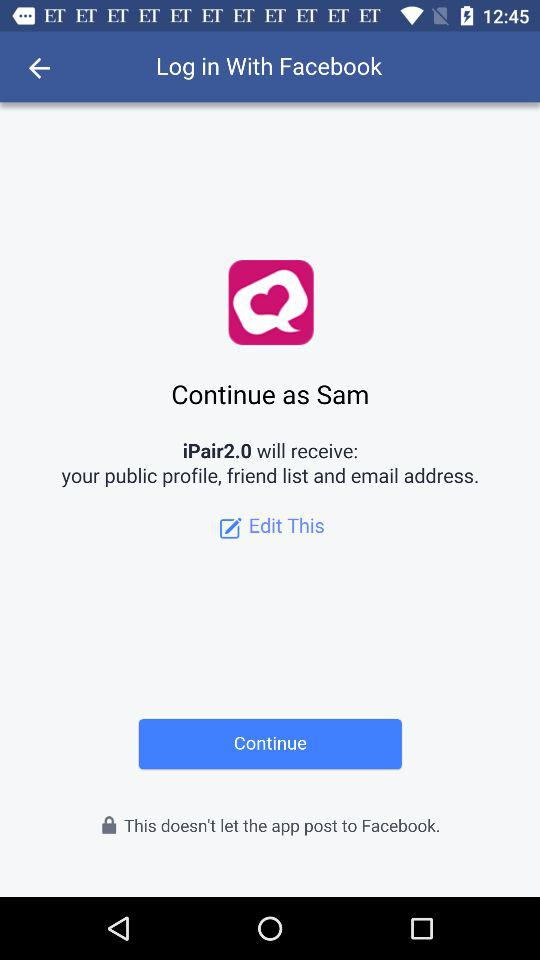What is the name of the user? The name of the user is Sam. 